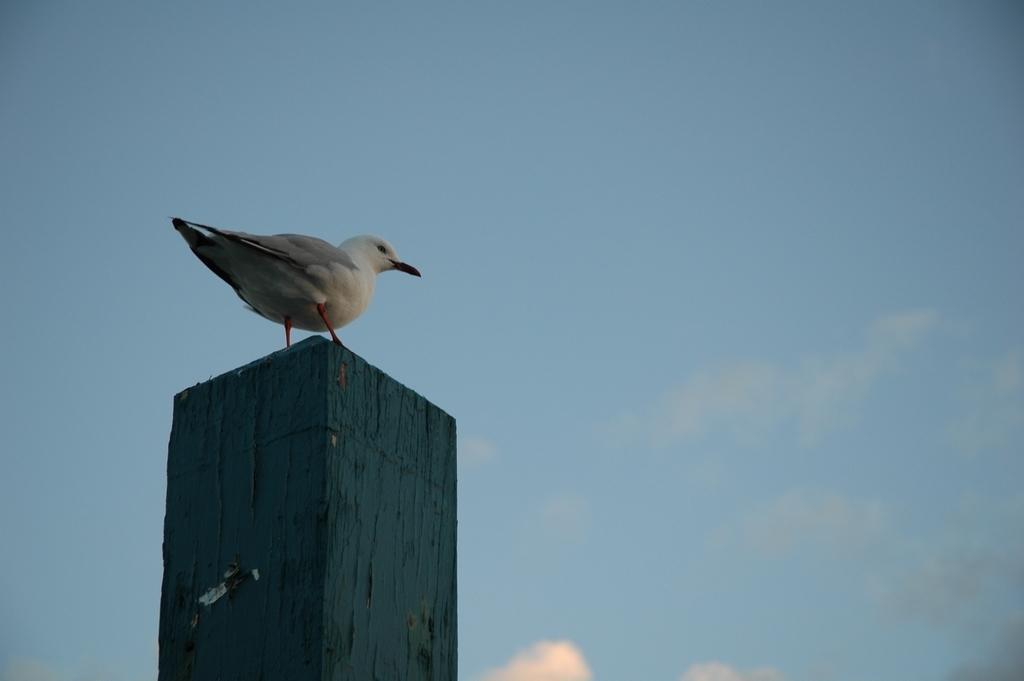How would you summarize this image in a sentence or two? In this image there is a bird on the pillar. In the background of the image there is sky. 